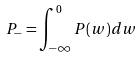<formula> <loc_0><loc_0><loc_500><loc_500>P _ { - } = \int _ { - \infty } ^ { 0 } P ( w ) d w</formula> 